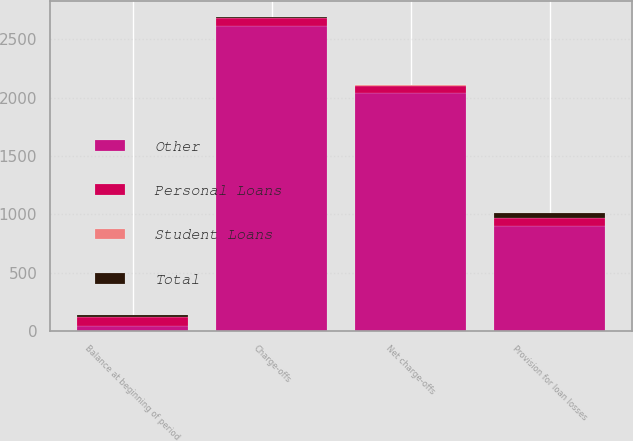Convert chart. <chart><loc_0><loc_0><loc_500><loc_500><stacked_bar_chart><ecel><fcel>Balance at beginning of period<fcel>Provision for loan losses<fcel>Charge-offs<fcel>Net charge-offs<nl><fcel>Other<fcel>42<fcel>897<fcel>2615<fcel>2036<nl><fcel>Personal Loans<fcel>76<fcel>73<fcel>69<fcel>67<nl><fcel>Total<fcel>18<fcel>42<fcel>7<fcel>7<nl><fcel>Student Loans<fcel>1<fcel>1<fcel>2<fcel>2<nl></chart> 